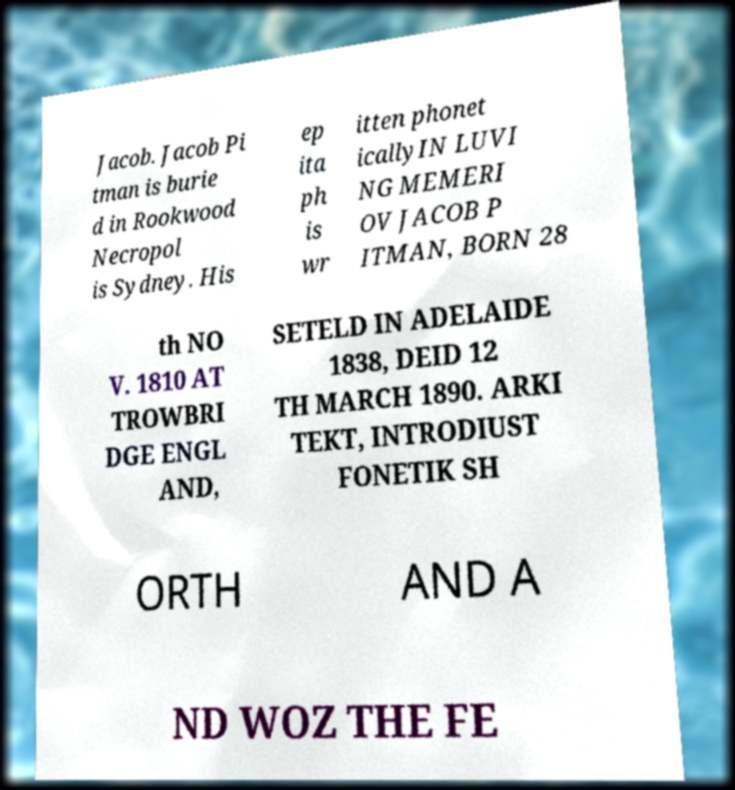Can you read and provide the text displayed in the image?This photo seems to have some interesting text. Can you extract and type it out for me? Jacob. Jacob Pi tman is burie d in Rookwood Necropol is Sydney. His ep ita ph is wr itten phonet icallyIN LUVI NG MEMERI OV JACOB P ITMAN, BORN 28 th NO V. 1810 AT TROWBRI DGE ENGL AND, SETELD IN ADELAIDE 1838, DEID 12 TH MARCH 1890. ARKI TEKT, INTRODIUST FONETIK SH ORTH AND A ND WOZ THE FE 